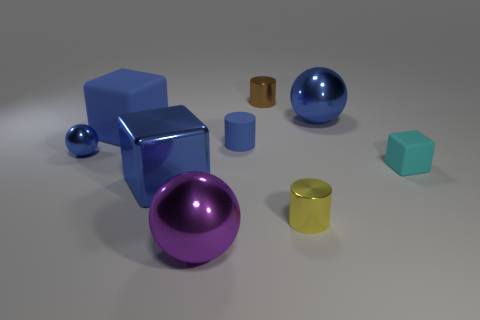Do the large matte block and the ball that is to the right of the large purple object have the same color?
Your response must be concise. Yes. There is a small shiny object that is in front of the blue metallic sphere to the left of the small brown metallic cylinder; what is its color?
Provide a short and direct response. Yellow. There is a large metallic ball that is in front of the matte block on the right side of the purple metal object; are there any blue spheres on the left side of it?
Keep it short and to the point. Yes. There is a small cylinder that is made of the same material as the tiny yellow object; what color is it?
Your response must be concise. Brown. How many brown cylinders have the same material as the big purple object?
Keep it short and to the point. 1. Is the material of the yellow thing the same as the cube behind the small blue metallic thing?
Keep it short and to the point. No. What number of things are large blocks behind the blue cylinder or blue matte cylinders?
Your answer should be compact. 2. There is a rubber cube to the left of the large blue object that is behind the matte block that is to the left of the tiny block; how big is it?
Keep it short and to the point. Large. There is a small sphere that is the same color as the big matte block; what is its material?
Provide a short and direct response. Metal. Is there anything else that is the same shape as the large matte object?
Your answer should be very brief. Yes. 